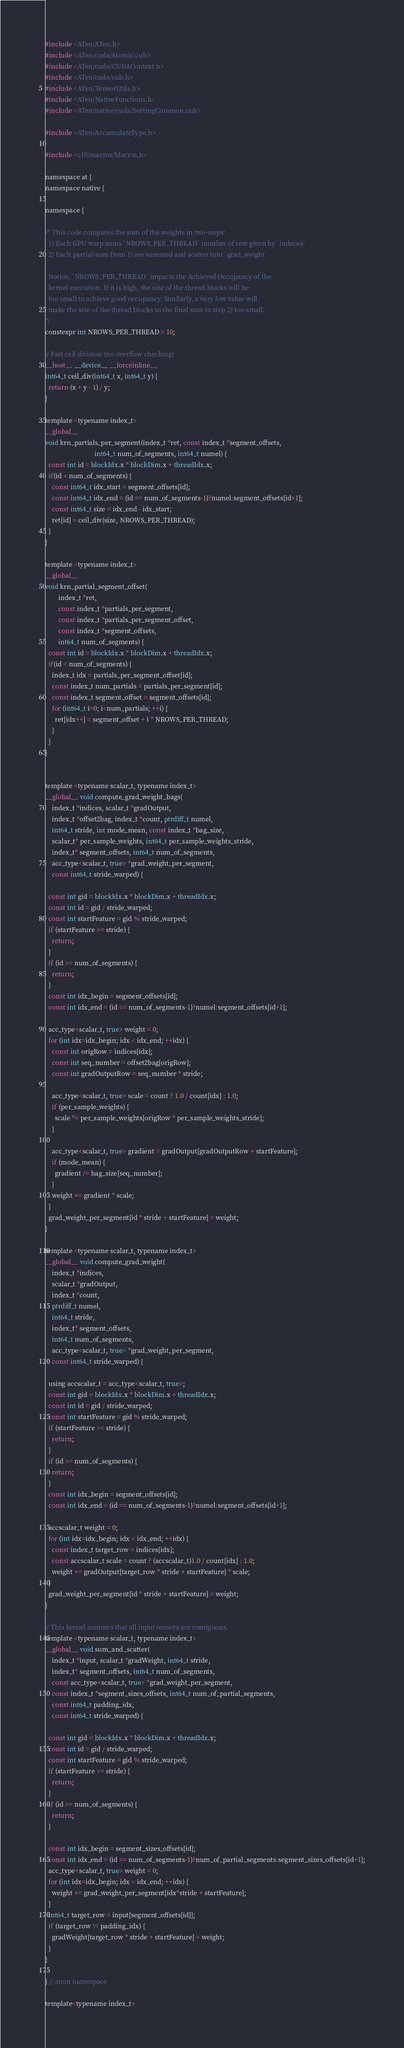<code> <loc_0><loc_0><loc_500><loc_500><_Cuda_>#include <ATen/ATen.h>
#include <ATen/cuda/Atomic.cuh>
#include <ATen/cuda/CUDAContext.h>
#include <ATen/cuda/cub.h>
#include <ATen/TensorUtils.h>
#include <ATen/NativeFunctions.h>
#include <ATen/native/cuda/SortingCommon.cuh>

#include <ATen/AccumulateType.h>

#include <c10/macros/Macros.h>

namespace at {
namespace native {

namespace {

/* This code computes the sum of the weights in two-steps:
  1) Each GPU warp sums `NROWS_PER_THREAD` number of row given by `indeces`
  2) Each partial-sum from 1) are summed and scatter into `grad_weight`

  Notice, `NROWS_PER_THREAD` impacts the Achieved Occupancy of the
  kernel execution. If it is high, the size of the thread blocks will be
  too small to achieve good occupancy. Similarly, a very low value will
  make the size of the thread blocks in the final sum in step 2) too small.
*/
constexpr int NROWS_PER_THREAD = 10;

// Fast ceil division (no overflow checking)
__host__ __device__ __forceinline__
int64_t ceil_div(int64_t x, int64_t y) {
  return (x + y - 1) / y;
}

template <typename index_t>
__global__
void krn_partials_per_segment(index_t *ret, const index_t *segment_offsets,
                              int64_t num_of_segments, int64_t numel) {
  const int id = blockIdx.x * blockDim.x + threadIdx.x;
  if(id < num_of_segments) {
    const int64_t idx_start = segment_offsets[id];
    const int64_t idx_end = (id == num_of_segments-1)?numel:segment_offsets[id+1];
    const int64_t size = idx_end - idx_start;
    ret[id] = ceil_div(size, NROWS_PER_THREAD);
  }
}

template <typename index_t>
__global__
void krn_partial_segment_offset(
        index_t *ret,
        const index_t *partials_per_segment,
        const index_t *partials_per_segment_offset,
        const index_t *segment_offsets,
        int64_t num_of_segments) {
  const int id = blockIdx.x * blockDim.x + threadIdx.x;
  if(id < num_of_segments) {
    index_t idx = partials_per_segment_offset[id];
    const index_t num_partials = partials_per_segment[id];
    const index_t segment_offset = segment_offsets[id];
    for (int64_t i=0; i<num_partials; ++i) {
      ret[idx++] = segment_offset + i * NROWS_PER_THREAD;
    }
  }
}


template <typename scalar_t, typename index_t>
__global__ void compute_grad_weight_bags(
    index_t *indices, scalar_t *gradOutput,
    index_t *offset2bag, index_t *count, ptrdiff_t numel,
    int64_t stride, int mode_mean, const index_t *bag_size,
    scalar_t* per_sample_weights, int64_t per_sample_weights_stride,
    index_t* segment_offsets, int64_t num_of_segments,
    acc_type<scalar_t, true> *grad_weight_per_segment,
    const int64_t stride_warped) {

  const int gid = blockIdx.x * blockDim.x + threadIdx.x;
  const int id = gid / stride_warped;
  const int startFeature = gid % stride_warped;
  if (startFeature >= stride) {
    return;
  }
  if (id >= num_of_segments) {
    return;
  }
  const int idx_begin = segment_offsets[id];
  const int idx_end = (id == num_of_segments-1)?numel:segment_offsets[id+1];

  acc_type<scalar_t, true> weight = 0;
  for (int idx=idx_begin; idx < idx_end; ++idx) {
    const int origRow = indices[idx];
    const int seq_number = offset2bag[origRow];
    const int gradOutputRow = seq_number * stride;

    acc_type<scalar_t, true> scale = count ? 1.0 / count[idx] : 1.0;
    if (per_sample_weights) {
      scale *= per_sample_weights[origRow * per_sample_weights_stride];
    }

    acc_type<scalar_t, true> gradient = gradOutput[gradOutputRow + startFeature];
    if (mode_mean) {
      gradient /= bag_size[seq_number];
    }
    weight += gradient * scale;
  }
  grad_weight_per_segment[id * stride + startFeature] = weight;
}

template <typename scalar_t, typename index_t>
__global__ void compute_grad_weight(
    index_t *indices,
    scalar_t *gradOutput,
    index_t *count,
    ptrdiff_t numel,
    int64_t stride,
    index_t* segment_offsets,
    int64_t num_of_segments,
    acc_type<scalar_t, true> *grad_weight_per_segment,
    const int64_t stride_warped) {

  using accscalar_t = acc_type<scalar_t, true>;
  const int gid = blockIdx.x * blockDim.x + threadIdx.x;
  const int id = gid / stride_warped;
  const int startFeature = gid % stride_warped;
  if (startFeature >= stride) {
    return;
  }
  if (id >= num_of_segments) {
    return;
  }
  const int idx_begin = segment_offsets[id];
  const int idx_end = (id == num_of_segments-1)?numel:segment_offsets[id+1];

  accscalar_t weight = 0;
  for (int idx=idx_begin; idx < idx_end; ++idx) {
    const index_t target_row = indices[idx];
    const accscalar_t scale = count ? (accscalar_t)1.0 / count[idx] : 1.0;
    weight += gradOutput[target_row * stride + startFeature] * scale;
  }
  grad_weight_per_segment[id * stride + startFeature] = weight;
}

// This kernel assumes that all input tensors are contiguous.
template <typename scalar_t, typename index_t>
__global__ void sum_and_scatter(
    index_t *input, scalar_t *gradWeight, int64_t stride,
    index_t* segment_offsets, int64_t num_of_segments,
    const acc_type<scalar_t, true> *grad_weight_per_segment,
    const index_t *segment_sizes_offsets, int64_t num_of_partial_segments,
    const int64_t padding_idx,
    const int64_t stride_warped) {

  const int gid = blockIdx.x * blockDim.x + threadIdx.x;
  const int id = gid / stride_warped;
  const int startFeature = gid % stride_warped;
  if (startFeature >= stride) {
    return;
  }
  if (id >= num_of_segments) {
    return;
  }

  const int idx_begin = segment_sizes_offsets[id];
  const int idx_end = (id == num_of_segments-1)?num_of_partial_segments:segment_sizes_offsets[id+1];
  acc_type<scalar_t, true> weight = 0;
  for (int idx=idx_begin; idx < idx_end; ++idx) {
    weight += grad_weight_per_segment[idx*stride + startFeature];
  }
  int64_t target_row = input[segment_offsets[id]];
  if (target_row != padding_idx) {
    gradWeight[target_row * stride + startFeature] = weight;
  }
}

} // anon namespace

template<typename index_t></code> 